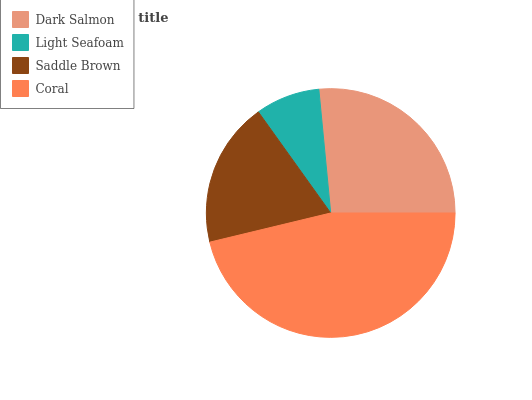Is Light Seafoam the minimum?
Answer yes or no. Yes. Is Coral the maximum?
Answer yes or no. Yes. Is Saddle Brown the minimum?
Answer yes or no. No. Is Saddle Brown the maximum?
Answer yes or no. No. Is Saddle Brown greater than Light Seafoam?
Answer yes or no. Yes. Is Light Seafoam less than Saddle Brown?
Answer yes or no. Yes. Is Light Seafoam greater than Saddle Brown?
Answer yes or no. No. Is Saddle Brown less than Light Seafoam?
Answer yes or no. No. Is Dark Salmon the high median?
Answer yes or no. Yes. Is Saddle Brown the low median?
Answer yes or no. Yes. Is Saddle Brown the high median?
Answer yes or no. No. Is Coral the low median?
Answer yes or no. No. 